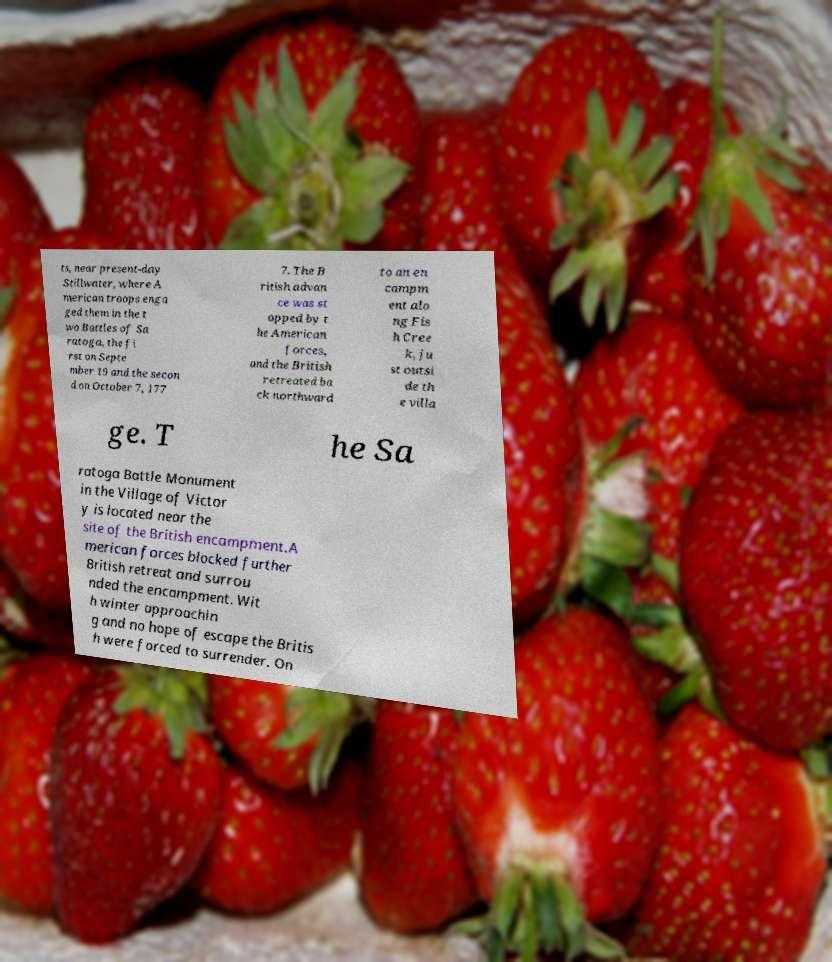Could you assist in decoding the text presented in this image and type it out clearly? ts, near present-day Stillwater, where A merican troops enga ged them in the t wo Battles of Sa ratoga, the fi rst on Septe mber 19 and the secon d on October 7, 177 7. The B ritish advan ce was st opped by t he American forces, and the British retreated ba ck northward to an en campm ent alo ng Fis h Cree k, ju st outsi de th e villa ge. T he Sa ratoga Battle Monument in the Village of Victor y is located near the site of the British encampment.A merican forces blocked further British retreat and surrou nded the encampment. Wit h winter approachin g and no hope of escape the Britis h were forced to surrender. On 